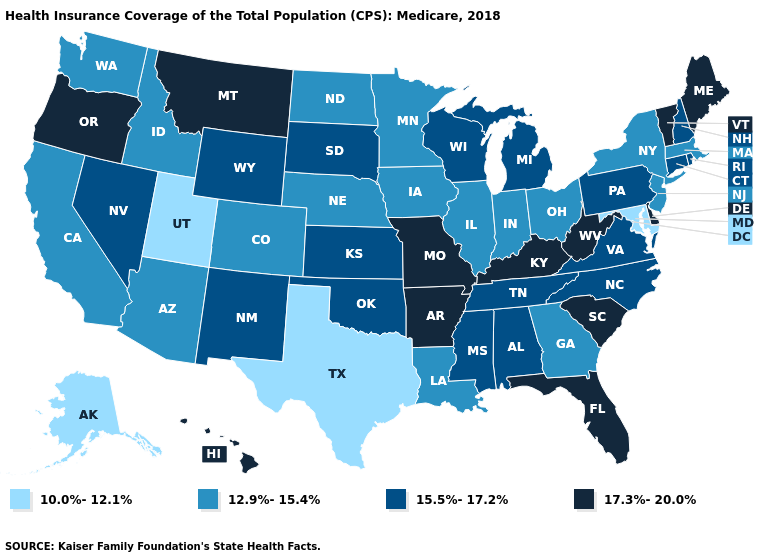Is the legend a continuous bar?
Quick response, please. No. Which states hav the highest value in the South?
Keep it brief. Arkansas, Delaware, Florida, Kentucky, South Carolina, West Virginia. Does Alaska have the lowest value in the USA?
Answer briefly. Yes. Which states have the lowest value in the USA?
Give a very brief answer. Alaska, Maryland, Texas, Utah. Name the states that have a value in the range 17.3%-20.0%?
Be succinct. Arkansas, Delaware, Florida, Hawaii, Kentucky, Maine, Missouri, Montana, Oregon, South Carolina, Vermont, West Virginia. How many symbols are there in the legend?
Quick response, please. 4. Which states have the highest value in the USA?
Write a very short answer. Arkansas, Delaware, Florida, Hawaii, Kentucky, Maine, Missouri, Montana, Oregon, South Carolina, Vermont, West Virginia. Name the states that have a value in the range 12.9%-15.4%?
Quick response, please. Arizona, California, Colorado, Georgia, Idaho, Illinois, Indiana, Iowa, Louisiana, Massachusetts, Minnesota, Nebraska, New Jersey, New York, North Dakota, Ohio, Washington. Does the first symbol in the legend represent the smallest category?
Keep it brief. Yes. Name the states that have a value in the range 12.9%-15.4%?
Be succinct. Arizona, California, Colorado, Georgia, Idaho, Illinois, Indiana, Iowa, Louisiana, Massachusetts, Minnesota, Nebraska, New Jersey, New York, North Dakota, Ohio, Washington. What is the value of Ohio?
Answer briefly. 12.9%-15.4%. What is the lowest value in states that border California?
Write a very short answer. 12.9%-15.4%. Name the states that have a value in the range 17.3%-20.0%?
Answer briefly. Arkansas, Delaware, Florida, Hawaii, Kentucky, Maine, Missouri, Montana, Oregon, South Carolina, Vermont, West Virginia. What is the value of Missouri?
Concise answer only. 17.3%-20.0%. What is the value of Iowa?
Give a very brief answer. 12.9%-15.4%. 